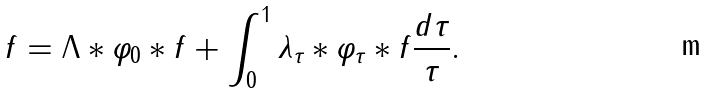Convert formula to latex. <formula><loc_0><loc_0><loc_500><loc_500>f = \Lambda \ast \varphi _ { 0 } \ast f + \int _ { 0 } ^ { 1 } \lambda _ { \tau } \ast \varphi _ { \tau } \ast f \frac { d \tau } { \tau } .</formula> 